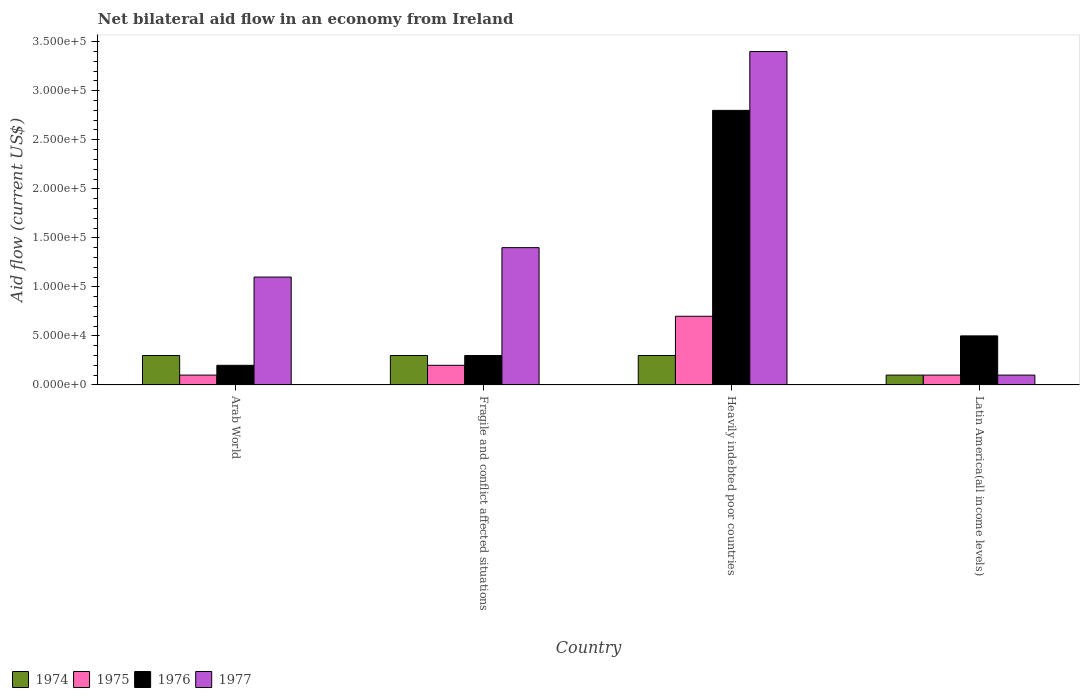How many different coloured bars are there?
Keep it short and to the point. 4. Are the number of bars on each tick of the X-axis equal?
Your answer should be compact. Yes. What is the label of the 2nd group of bars from the left?
Provide a succinct answer. Fragile and conflict affected situations. In which country was the net bilateral aid flow in 1976 maximum?
Your answer should be compact. Heavily indebted poor countries. In which country was the net bilateral aid flow in 1977 minimum?
Your answer should be compact. Latin America(all income levels). What is the total net bilateral aid flow in 1976 in the graph?
Keep it short and to the point. 3.80e+05. What is the difference between the net bilateral aid flow in 1975 in Fragile and conflict affected situations and that in Latin America(all income levels)?
Provide a short and direct response. 10000. What is the difference between the net bilateral aid flow in 1977 in Arab World and the net bilateral aid flow in 1976 in Fragile and conflict affected situations?
Provide a succinct answer. 8.00e+04. What is the average net bilateral aid flow in 1976 per country?
Provide a succinct answer. 9.50e+04. What is the ratio of the net bilateral aid flow in 1977 in Fragile and conflict affected situations to that in Heavily indebted poor countries?
Your response must be concise. 0.41. What is the difference between the highest and the lowest net bilateral aid flow in 1977?
Make the answer very short. 3.30e+05. What does the 2nd bar from the right in Arab World represents?
Offer a very short reply. 1976. How many bars are there?
Your answer should be very brief. 16. How many countries are there in the graph?
Your answer should be very brief. 4. What is the difference between two consecutive major ticks on the Y-axis?
Your answer should be compact. 5.00e+04. Are the values on the major ticks of Y-axis written in scientific E-notation?
Ensure brevity in your answer.  Yes. Does the graph contain grids?
Make the answer very short. No. How many legend labels are there?
Your answer should be compact. 4. What is the title of the graph?
Give a very brief answer. Net bilateral aid flow in an economy from Ireland. What is the label or title of the X-axis?
Offer a terse response. Country. What is the Aid flow (current US$) of 1976 in Arab World?
Your answer should be very brief. 2.00e+04. What is the Aid flow (current US$) of 1977 in Arab World?
Your answer should be very brief. 1.10e+05. What is the Aid flow (current US$) of 1976 in Fragile and conflict affected situations?
Make the answer very short. 3.00e+04. What is the Aid flow (current US$) in 1974 in Heavily indebted poor countries?
Your answer should be compact. 3.00e+04. What is the Aid flow (current US$) in 1975 in Heavily indebted poor countries?
Provide a succinct answer. 7.00e+04. What is the Aid flow (current US$) in 1976 in Heavily indebted poor countries?
Provide a short and direct response. 2.80e+05. What is the Aid flow (current US$) in 1977 in Heavily indebted poor countries?
Your response must be concise. 3.40e+05. What is the Aid flow (current US$) of 1974 in Latin America(all income levels)?
Keep it short and to the point. 10000. What is the Aid flow (current US$) of 1976 in Latin America(all income levels)?
Make the answer very short. 5.00e+04. What is the Aid flow (current US$) in 1977 in Latin America(all income levels)?
Give a very brief answer. 10000. Across all countries, what is the maximum Aid flow (current US$) in 1975?
Give a very brief answer. 7.00e+04. Across all countries, what is the maximum Aid flow (current US$) in 1976?
Make the answer very short. 2.80e+05. Across all countries, what is the maximum Aid flow (current US$) of 1977?
Your answer should be very brief. 3.40e+05. Across all countries, what is the minimum Aid flow (current US$) of 1974?
Your answer should be very brief. 10000. Across all countries, what is the minimum Aid flow (current US$) in 1975?
Offer a very short reply. 10000. Across all countries, what is the minimum Aid flow (current US$) of 1976?
Make the answer very short. 2.00e+04. What is the total Aid flow (current US$) in 1975 in the graph?
Keep it short and to the point. 1.10e+05. What is the total Aid flow (current US$) of 1977 in the graph?
Your response must be concise. 6.00e+05. What is the difference between the Aid flow (current US$) of 1974 in Arab World and that in Fragile and conflict affected situations?
Your answer should be very brief. 0. What is the difference between the Aid flow (current US$) of 1975 in Arab World and that in Fragile and conflict affected situations?
Offer a very short reply. -10000. What is the difference between the Aid flow (current US$) in 1977 in Arab World and that in Fragile and conflict affected situations?
Ensure brevity in your answer.  -3.00e+04. What is the difference between the Aid flow (current US$) of 1974 in Arab World and that in Heavily indebted poor countries?
Give a very brief answer. 0. What is the difference between the Aid flow (current US$) in 1975 in Arab World and that in Heavily indebted poor countries?
Make the answer very short. -6.00e+04. What is the difference between the Aid flow (current US$) in 1975 in Arab World and that in Latin America(all income levels)?
Provide a short and direct response. 0. What is the difference between the Aid flow (current US$) in 1976 in Arab World and that in Latin America(all income levels)?
Offer a very short reply. -3.00e+04. What is the difference between the Aid flow (current US$) in 1975 in Fragile and conflict affected situations and that in Heavily indebted poor countries?
Make the answer very short. -5.00e+04. What is the difference between the Aid flow (current US$) of 1976 in Fragile and conflict affected situations and that in Heavily indebted poor countries?
Your answer should be very brief. -2.50e+05. What is the difference between the Aid flow (current US$) in 1977 in Fragile and conflict affected situations and that in Heavily indebted poor countries?
Make the answer very short. -2.00e+05. What is the difference between the Aid flow (current US$) in 1975 in Fragile and conflict affected situations and that in Latin America(all income levels)?
Your answer should be compact. 10000. What is the difference between the Aid flow (current US$) of 1974 in Heavily indebted poor countries and that in Latin America(all income levels)?
Make the answer very short. 2.00e+04. What is the difference between the Aid flow (current US$) of 1976 in Heavily indebted poor countries and that in Latin America(all income levels)?
Provide a succinct answer. 2.30e+05. What is the difference between the Aid flow (current US$) in 1974 in Arab World and the Aid flow (current US$) in 1975 in Fragile and conflict affected situations?
Your response must be concise. 10000. What is the difference between the Aid flow (current US$) of 1974 in Arab World and the Aid flow (current US$) of 1976 in Fragile and conflict affected situations?
Provide a short and direct response. 0. What is the difference between the Aid flow (current US$) in 1974 in Arab World and the Aid flow (current US$) in 1977 in Fragile and conflict affected situations?
Provide a succinct answer. -1.10e+05. What is the difference between the Aid flow (current US$) of 1976 in Arab World and the Aid flow (current US$) of 1977 in Fragile and conflict affected situations?
Your response must be concise. -1.20e+05. What is the difference between the Aid flow (current US$) of 1974 in Arab World and the Aid flow (current US$) of 1976 in Heavily indebted poor countries?
Ensure brevity in your answer.  -2.50e+05. What is the difference between the Aid flow (current US$) in 1974 in Arab World and the Aid flow (current US$) in 1977 in Heavily indebted poor countries?
Provide a short and direct response. -3.10e+05. What is the difference between the Aid flow (current US$) in 1975 in Arab World and the Aid flow (current US$) in 1976 in Heavily indebted poor countries?
Give a very brief answer. -2.70e+05. What is the difference between the Aid flow (current US$) of 1975 in Arab World and the Aid flow (current US$) of 1977 in Heavily indebted poor countries?
Provide a short and direct response. -3.30e+05. What is the difference between the Aid flow (current US$) of 1976 in Arab World and the Aid flow (current US$) of 1977 in Heavily indebted poor countries?
Your answer should be compact. -3.20e+05. What is the difference between the Aid flow (current US$) in 1976 in Arab World and the Aid flow (current US$) in 1977 in Latin America(all income levels)?
Your response must be concise. 10000. What is the difference between the Aid flow (current US$) in 1974 in Fragile and conflict affected situations and the Aid flow (current US$) in 1975 in Heavily indebted poor countries?
Offer a very short reply. -4.00e+04. What is the difference between the Aid flow (current US$) of 1974 in Fragile and conflict affected situations and the Aid flow (current US$) of 1976 in Heavily indebted poor countries?
Offer a terse response. -2.50e+05. What is the difference between the Aid flow (current US$) of 1974 in Fragile and conflict affected situations and the Aid flow (current US$) of 1977 in Heavily indebted poor countries?
Your answer should be very brief. -3.10e+05. What is the difference between the Aid flow (current US$) of 1975 in Fragile and conflict affected situations and the Aid flow (current US$) of 1977 in Heavily indebted poor countries?
Ensure brevity in your answer.  -3.20e+05. What is the difference between the Aid flow (current US$) of 1976 in Fragile and conflict affected situations and the Aid flow (current US$) of 1977 in Heavily indebted poor countries?
Give a very brief answer. -3.10e+05. What is the difference between the Aid flow (current US$) of 1974 in Fragile and conflict affected situations and the Aid flow (current US$) of 1976 in Latin America(all income levels)?
Make the answer very short. -2.00e+04. What is the difference between the Aid flow (current US$) of 1976 in Fragile and conflict affected situations and the Aid flow (current US$) of 1977 in Latin America(all income levels)?
Ensure brevity in your answer.  2.00e+04. What is the difference between the Aid flow (current US$) in 1975 in Heavily indebted poor countries and the Aid flow (current US$) in 1976 in Latin America(all income levels)?
Provide a short and direct response. 2.00e+04. What is the difference between the Aid flow (current US$) of 1975 in Heavily indebted poor countries and the Aid flow (current US$) of 1977 in Latin America(all income levels)?
Provide a succinct answer. 6.00e+04. What is the average Aid flow (current US$) of 1974 per country?
Make the answer very short. 2.50e+04. What is the average Aid flow (current US$) of 1975 per country?
Provide a succinct answer. 2.75e+04. What is the average Aid flow (current US$) in 1976 per country?
Ensure brevity in your answer.  9.50e+04. What is the difference between the Aid flow (current US$) of 1974 and Aid flow (current US$) of 1975 in Arab World?
Make the answer very short. 2.00e+04. What is the difference between the Aid flow (current US$) of 1974 and Aid flow (current US$) of 1977 in Arab World?
Your response must be concise. -8.00e+04. What is the difference between the Aid flow (current US$) of 1976 and Aid flow (current US$) of 1977 in Arab World?
Provide a succinct answer. -9.00e+04. What is the difference between the Aid flow (current US$) of 1974 and Aid flow (current US$) of 1975 in Fragile and conflict affected situations?
Make the answer very short. 10000. What is the difference between the Aid flow (current US$) of 1974 and Aid flow (current US$) of 1977 in Fragile and conflict affected situations?
Your answer should be very brief. -1.10e+05. What is the difference between the Aid flow (current US$) of 1975 and Aid flow (current US$) of 1976 in Fragile and conflict affected situations?
Your answer should be very brief. -10000. What is the difference between the Aid flow (current US$) of 1975 and Aid flow (current US$) of 1977 in Fragile and conflict affected situations?
Ensure brevity in your answer.  -1.20e+05. What is the difference between the Aid flow (current US$) of 1976 and Aid flow (current US$) of 1977 in Fragile and conflict affected situations?
Your answer should be compact. -1.10e+05. What is the difference between the Aid flow (current US$) in 1974 and Aid flow (current US$) in 1975 in Heavily indebted poor countries?
Keep it short and to the point. -4.00e+04. What is the difference between the Aid flow (current US$) of 1974 and Aid flow (current US$) of 1977 in Heavily indebted poor countries?
Your answer should be very brief. -3.10e+05. What is the difference between the Aid flow (current US$) of 1975 and Aid flow (current US$) of 1976 in Heavily indebted poor countries?
Offer a terse response. -2.10e+05. What is the difference between the Aid flow (current US$) in 1975 and Aid flow (current US$) in 1977 in Heavily indebted poor countries?
Provide a short and direct response. -2.70e+05. What is the difference between the Aid flow (current US$) in 1976 and Aid flow (current US$) in 1977 in Heavily indebted poor countries?
Your response must be concise. -6.00e+04. What is the difference between the Aid flow (current US$) in 1974 and Aid flow (current US$) in 1976 in Latin America(all income levels)?
Your response must be concise. -4.00e+04. What is the difference between the Aid flow (current US$) in 1975 and Aid flow (current US$) in 1977 in Latin America(all income levels)?
Give a very brief answer. 0. What is the ratio of the Aid flow (current US$) of 1975 in Arab World to that in Fragile and conflict affected situations?
Your answer should be very brief. 0.5. What is the ratio of the Aid flow (current US$) of 1976 in Arab World to that in Fragile and conflict affected situations?
Ensure brevity in your answer.  0.67. What is the ratio of the Aid flow (current US$) in 1977 in Arab World to that in Fragile and conflict affected situations?
Your answer should be compact. 0.79. What is the ratio of the Aid flow (current US$) in 1975 in Arab World to that in Heavily indebted poor countries?
Your answer should be very brief. 0.14. What is the ratio of the Aid flow (current US$) in 1976 in Arab World to that in Heavily indebted poor countries?
Offer a very short reply. 0.07. What is the ratio of the Aid flow (current US$) of 1977 in Arab World to that in Heavily indebted poor countries?
Make the answer very short. 0.32. What is the ratio of the Aid flow (current US$) of 1974 in Arab World to that in Latin America(all income levels)?
Your answer should be very brief. 3. What is the ratio of the Aid flow (current US$) of 1975 in Arab World to that in Latin America(all income levels)?
Your answer should be compact. 1. What is the ratio of the Aid flow (current US$) in 1976 in Arab World to that in Latin America(all income levels)?
Offer a terse response. 0.4. What is the ratio of the Aid flow (current US$) in 1977 in Arab World to that in Latin America(all income levels)?
Keep it short and to the point. 11. What is the ratio of the Aid flow (current US$) of 1974 in Fragile and conflict affected situations to that in Heavily indebted poor countries?
Give a very brief answer. 1. What is the ratio of the Aid flow (current US$) of 1975 in Fragile and conflict affected situations to that in Heavily indebted poor countries?
Give a very brief answer. 0.29. What is the ratio of the Aid flow (current US$) in 1976 in Fragile and conflict affected situations to that in Heavily indebted poor countries?
Offer a terse response. 0.11. What is the ratio of the Aid flow (current US$) of 1977 in Fragile and conflict affected situations to that in Heavily indebted poor countries?
Offer a terse response. 0.41. What is the ratio of the Aid flow (current US$) in 1976 in Fragile and conflict affected situations to that in Latin America(all income levels)?
Keep it short and to the point. 0.6. What is the ratio of the Aid flow (current US$) of 1976 in Heavily indebted poor countries to that in Latin America(all income levels)?
Your answer should be very brief. 5.6. What is the ratio of the Aid flow (current US$) of 1977 in Heavily indebted poor countries to that in Latin America(all income levels)?
Your response must be concise. 34. What is the difference between the highest and the second highest Aid flow (current US$) in 1974?
Your answer should be compact. 0. What is the difference between the highest and the second highest Aid flow (current US$) of 1975?
Keep it short and to the point. 5.00e+04. What is the difference between the highest and the second highest Aid flow (current US$) in 1976?
Your response must be concise. 2.30e+05. What is the difference between the highest and the second highest Aid flow (current US$) of 1977?
Ensure brevity in your answer.  2.00e+05. What is the difference between the highest and the lowest Aid flow (current US$) in 1977?
Ensure brevity in your answer.  3.30e+05. 